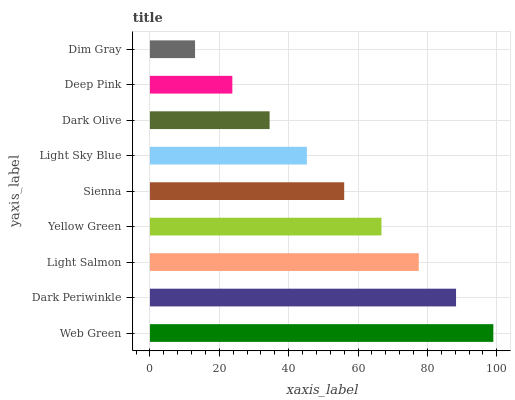Is Dim Gray the minimum?
Answer yes or no. Yes. Is Web Green the maximum?
Answer yes or no. Yes. Is Dark Periwinkle the minimum?
Answer yes or no. No. Is Dark Periwinkle the maximum?
Answer yes or no. No. Is Web Green greater than Dark Periwinkle?
Answer yes or no. Yes. Is Dark Periwinkle less than Web Green?
Answer yes or no. Yes. Is Dark Periwinkle greater than Web Green?
Answer yes or no. No. Is Web Green less than Dark Periwinkle?
Answer yes or no. No. Is Sienna the high median?
Answer yes or no. Yes. Is Sienna the low median?
Answer yes or no. Yes. Is Deep Pink the high median?
Answer yes or no. No. Is Deep Pink the low median?
Answer yes or no. No. 